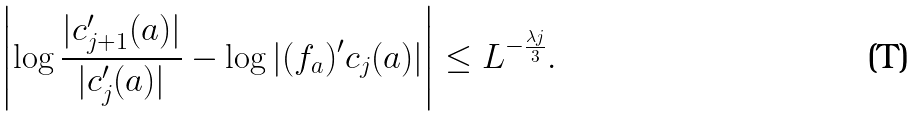<formula> <loc_0><loc_0><loc_500><loc_500>\left | \log \frac { | c _ { j + 1 } ^ { \prime } ( a ) | } { | c _ { j } ^ { \prime } ( a ) | } - \log | ( f _ { a } ) ^ { \prime } c _ { j } ( a ) | \right | \leq L ^ { - \frac { \lambda j } { 3 } } .</formula> 